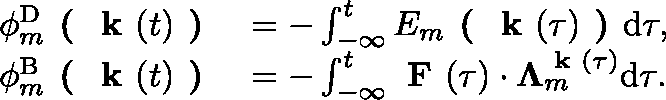Convert formula to latex. <formula><loc_0><loc_0><loc_500><loc_500>\begin{array} { r l } { \phi _ { m } ^ { D } ( k ( t ) ) } & { = - \int _ { - \infty } ^ { t } E _ { m } ( k ( \tau ) ) d \tau , } \\ { \phi _ { m } ^ { B } ( k ( t ) ) } & { = - \int _ { - \infty } ^ { t } F ( \tau ) \cdot \Lambda _ { m } ^ { k ( \tau ) } d \tau . } \end{array}</formula> 